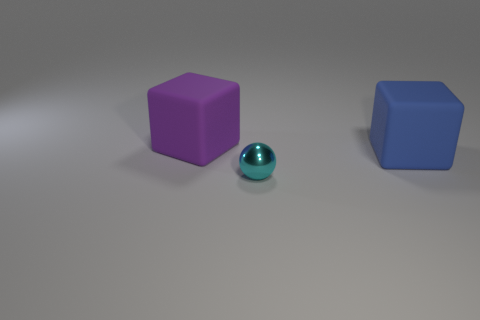What is the size of the other object that is the same material as the large purple object?
Keep it short and to the point. Large. There is a rubber block that is behind the blue object that is in front of the purple rubber object; how many large matte blocks are left of it?
Your response must be concise. 0. There is a metallic sphere; is its color the same as the matte object on the right side of the small ball?
Your answer should be very brief. No. What is the material of the large block in front of the rubber object that is behind the big object that is on the right side of the sphere?
Provide a succinct answer. Rubber. Does the thing that is behind the blue rubber thing have the same shape as the blue thing?
Your answer should be compact. Yes. What is the material of the object right of the sphere?
Your answer should be compact. Rubber. What number of metal things are purple blocks or large brown things?
Make the answer very short. 0. Is there a blue thing of the same size as the purple cube?
Provide a succinct answer. Yes. Are there more blue cubes behind the purple block than green matte cylinders?
Provide a succinct answer. No. How many large objects are yellow metallic things or rubber blocks?
Your response must be concise. 2. 